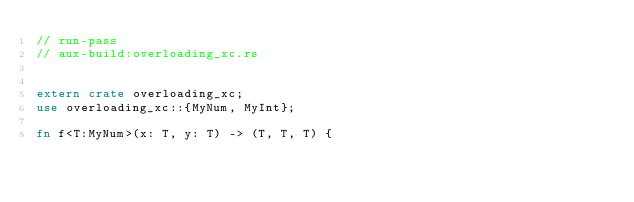<code> <loc_0><loc_0><loc_500><loc_500><_Rust_>// run-pass
// aux-build:overloading_xc.rs


extern crate overloading_xc;
use overloading_xc::{MyNum, MyInt};

fn f<T:MyNum>(x: T, y: T) -> (T, T, T) {</code> 